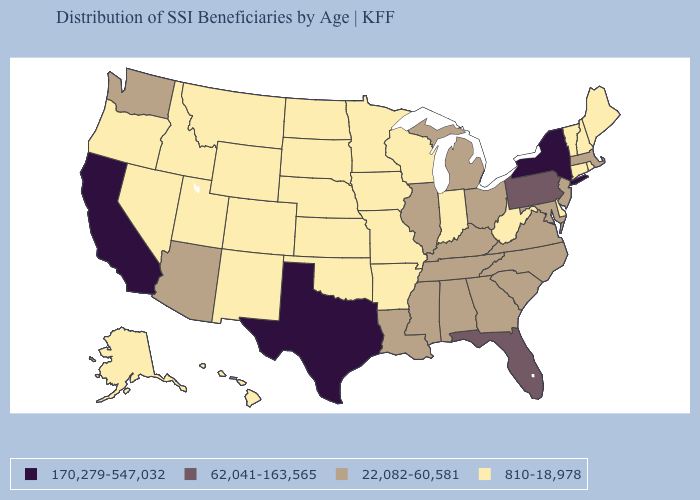What is the highest value in states that border Kansas?
Write a very short answer. 810-18,978. Which states have the lowest value in the USA?
Quick response, please. Alaska, Arkansas, Colorado, Connecticut, Delaware, Hawaii, Idaho, Indiana, Iowa, Kansas, Maine, Minnesota, Missouri, Montana, Nebraska, Nevada, New Hampshire, New Mexico, North Dakota, Oklahoma, Oregon, Rhode Island, South Dakota, Utah, Vermont, West Virginia, Wisconsin, Wyoming. What is the lowest value in the USA?
Answer briefly. 810-18,978. What is the value of North Carolina?
Quick response, please. 22,082-60,581. Does Connecticut have the same value as Washington?
Quick response, please. No. Which states hav the highest value in the Northeast?
Be succinct. New York. Name the states that have a value in the range 170,279-547,032?
Concise answer only. California, New York, Texas. Which states have the lowest value in the USA?
Answer briefly. Alaska, Arkansas, Colorado, Connecticut, Delaware, Hawaii, Idaho, Indiana, Iowa, Kansas, Maine, Minnesota, Missouri, Montana, Nebraska, Nevada, New Hampshire, New Mexico, North Dakota, Oklahoma, Oregon, Rhode Island, South Dakota, Utah, Vermont, West Virginia, Wisconsin, Wyoming. Name the states that have a value in the range 170,279-547,032?
Keep it brief. California, New York, Texas. Name the states that have a value in the range 810-18,978?
Give a very brief answer. Alaska, Arkansas, Colorado, Connecticut, Delaware, Hawaii, Idaho, Indiana, Iowa, Kansas, Maine, Minnesota, Missouri, Montana, Nebraska, Nevada, New Hampshire, New Mexico, North Dakota, Oklahoma, Oregon, Rhode Island, South Dakota, Utah, Vermont, West Virginia, Wisconsin, Wyoming. What is the value of Arkansas?
Be succinct. 810-18,978. Name the states that have a value in the range 62,041-163,565?
Be succinct. Florida, Pennsylvania. What is the value of Maryland?
Give a very brief answer. 22,082-60,581. Among the states that border Washington , which have the lowest value?
Quick response, please. Idaho, Oregon. What is the lowest value in the USA?
Quick response, please. 810-18,978. 